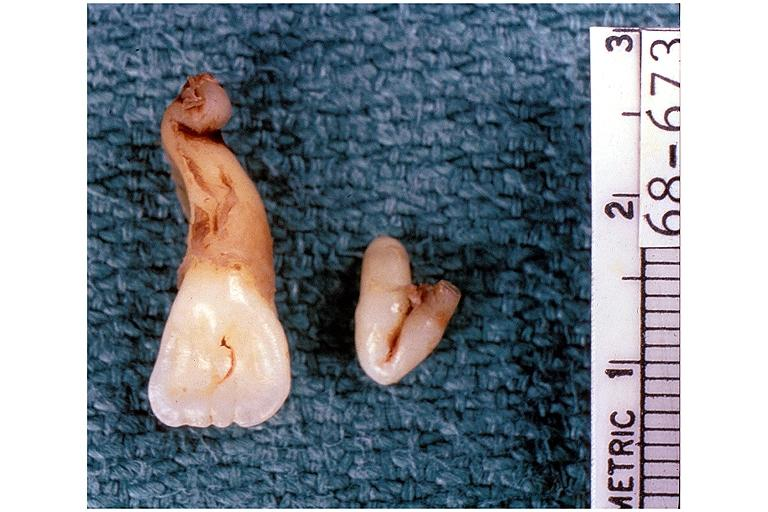does this image show dilaceration?
Answer the question using a single word or phrase. Yes 